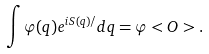<formula> <loc_0><loc_0><loc_500><loc_500>\int \varphi ( q ) e ^ { i S ( q ) / } d q = \varphi < O > .</formula> 